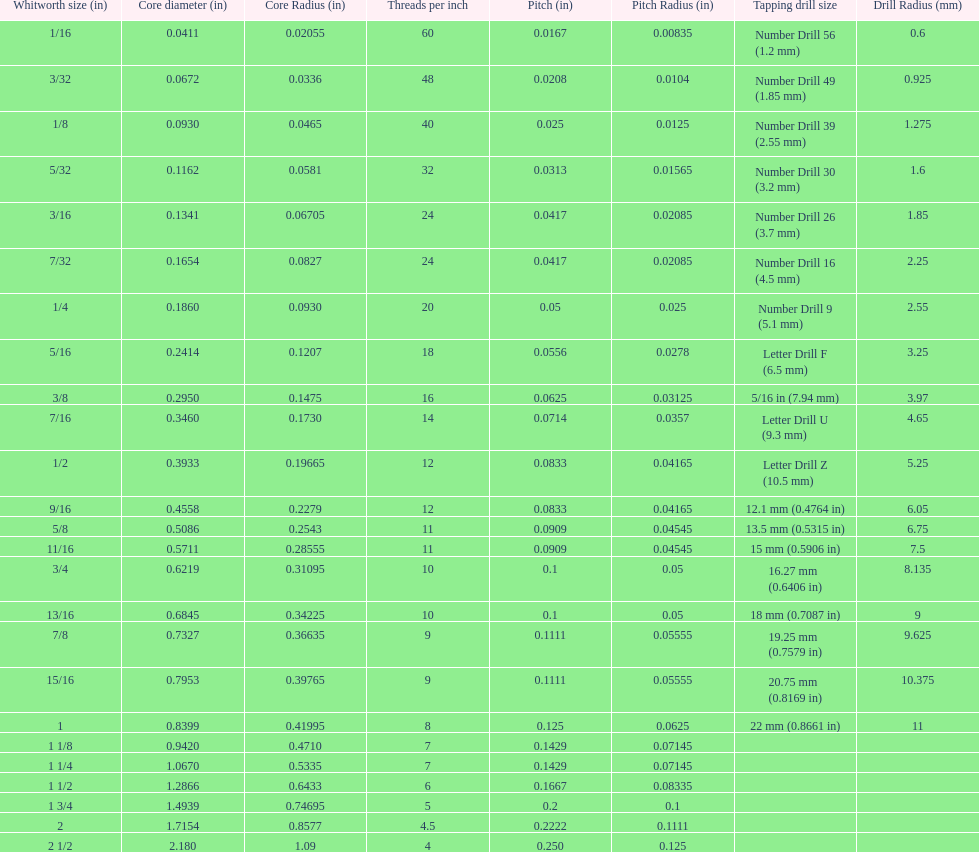What is the smallest core diameter (in)? 0.0411. 